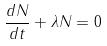Convert formula to latex. <formula><loc_0><loc_0><loc_500><loc_500>\frac { d N } { d t } + \lambda N = 0</formula> 